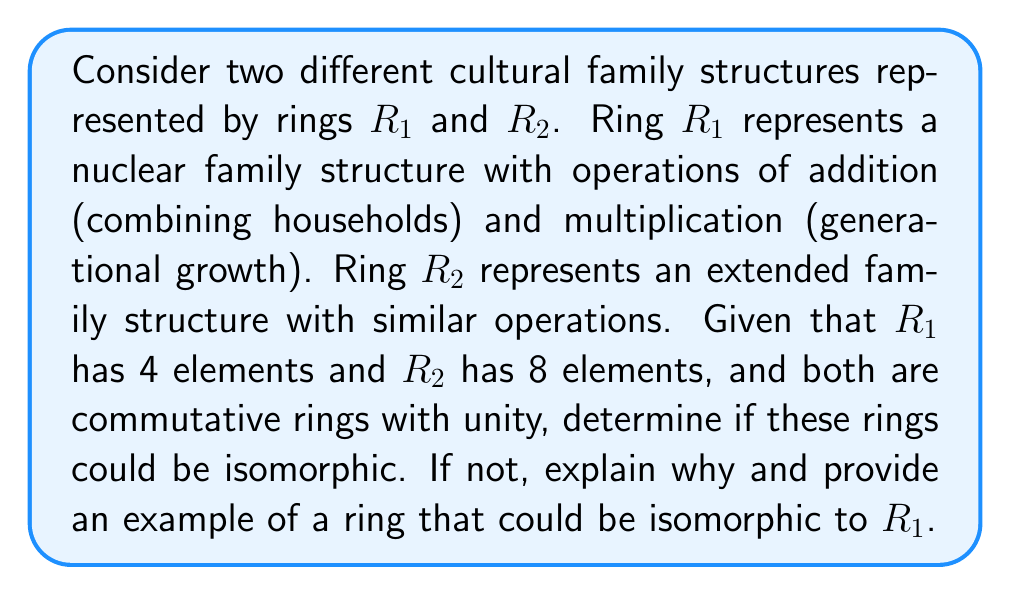Solve this math problem. To determine if rings $R_1$ and $R_2$ are isomorphic, we need to consider the following:

1. Definition of ring isomorphism: A ring isomorphism is a bijective function $f: R_1 \rightarrow R_2$ that preserves both addition and multiplication operations.

2. Properties of isomorphic rings:
   a) They have the same number of elements.
   b) They have the same algebraic structure.

3. Given information:
   a) $R_1$ has 4 elements
   b) $R_2$ has 8 elements
   c) Both are commutative rings with unity

Step 1: Compare the number of elements
$|R_1| = 4 \neq 8 = |R_2|$

Since $R_1$ and $R_2$ have a different number of elements, they cannot be isomorphic. An isomorphism requires a one-to-one correspondence between elements, which is impossible when the rings have different sizes.

Step 2: Identify a ring that could be isomorphic to $R_1$

To find a ring isomorphic to $R_1$, we need to consider rings with 4 elements. One such ring is $\mathbb{Z}_4$, the ring of integers modulo 4.

$\mathbb{Z}_4 = \{0, 1, 2, 3\}$ with addition and multiplication modulo 4.

To prove that $R_1$ and $\mathbb{Z}_4$ are isomorphic, we would need to establish a bijective function that preserves both addition and multiplication. However, without more information about the specific structure of $R_1$, we can only say that $\mathbb{Z}_4$ is a potential candidate for an isomorphism.

The isomorphism between family structures and mathematical rings illustrates that while different cultures may have varying family sizes (represented by the number of ring elements), the underlying algebraic structure (representing relationships and interactions) can be similar across cultures with the same family size.
Answer: $R_1$ and $R_2$ are not isomorphic because they have a different number of elements (4 and 8, respectively). A ring that could potentially be isomorphic to $R_1$ is $\mathbb{Z}_4$, the ring of integers modulo 4. 